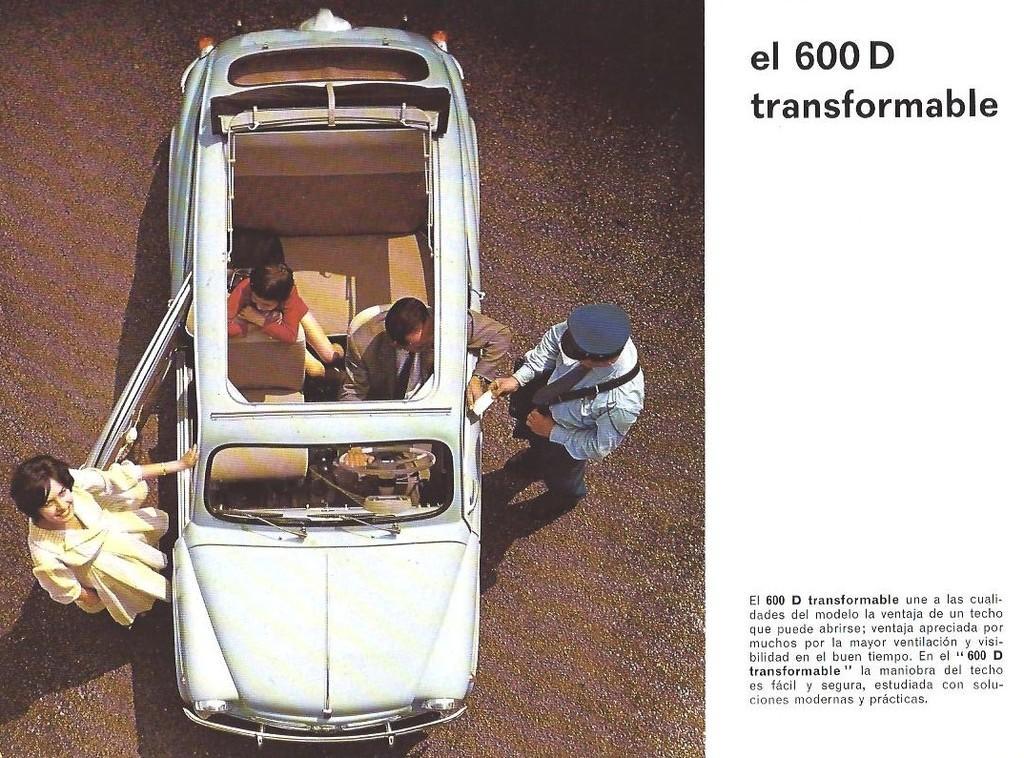Please provide a concise description of this image. In this picture we can see a car, we can see two persons are standing on the left side, there are two persons sitting in the car, on the right side there is some text. 